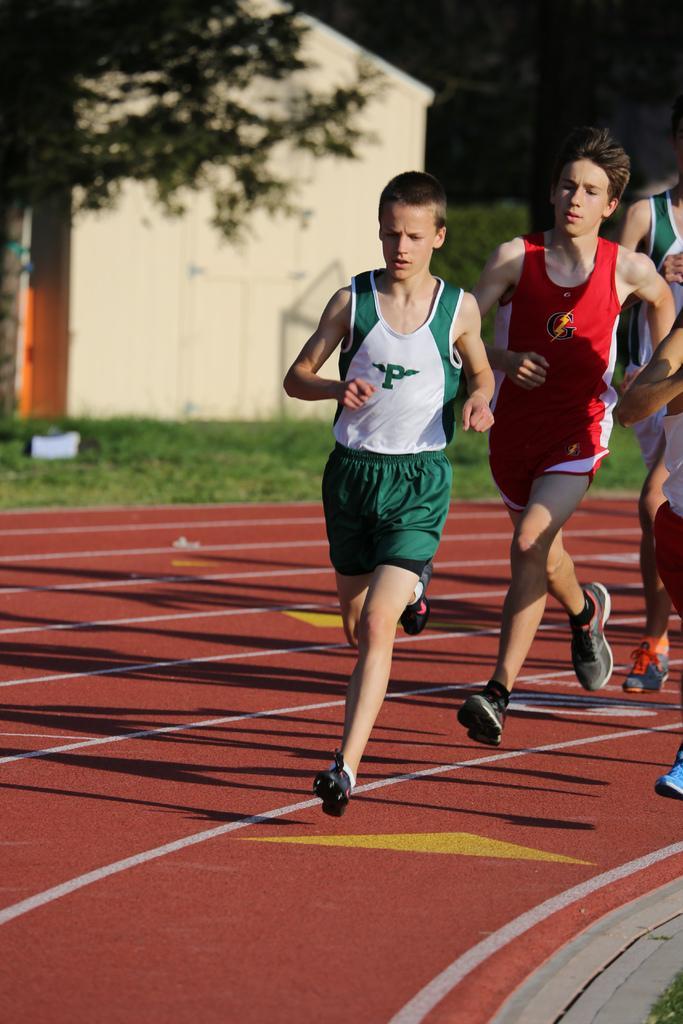How would you summarize this image in a sentence or two? It is a running race the boys are running on the ground,behind the ground there is a grass and some trees. 